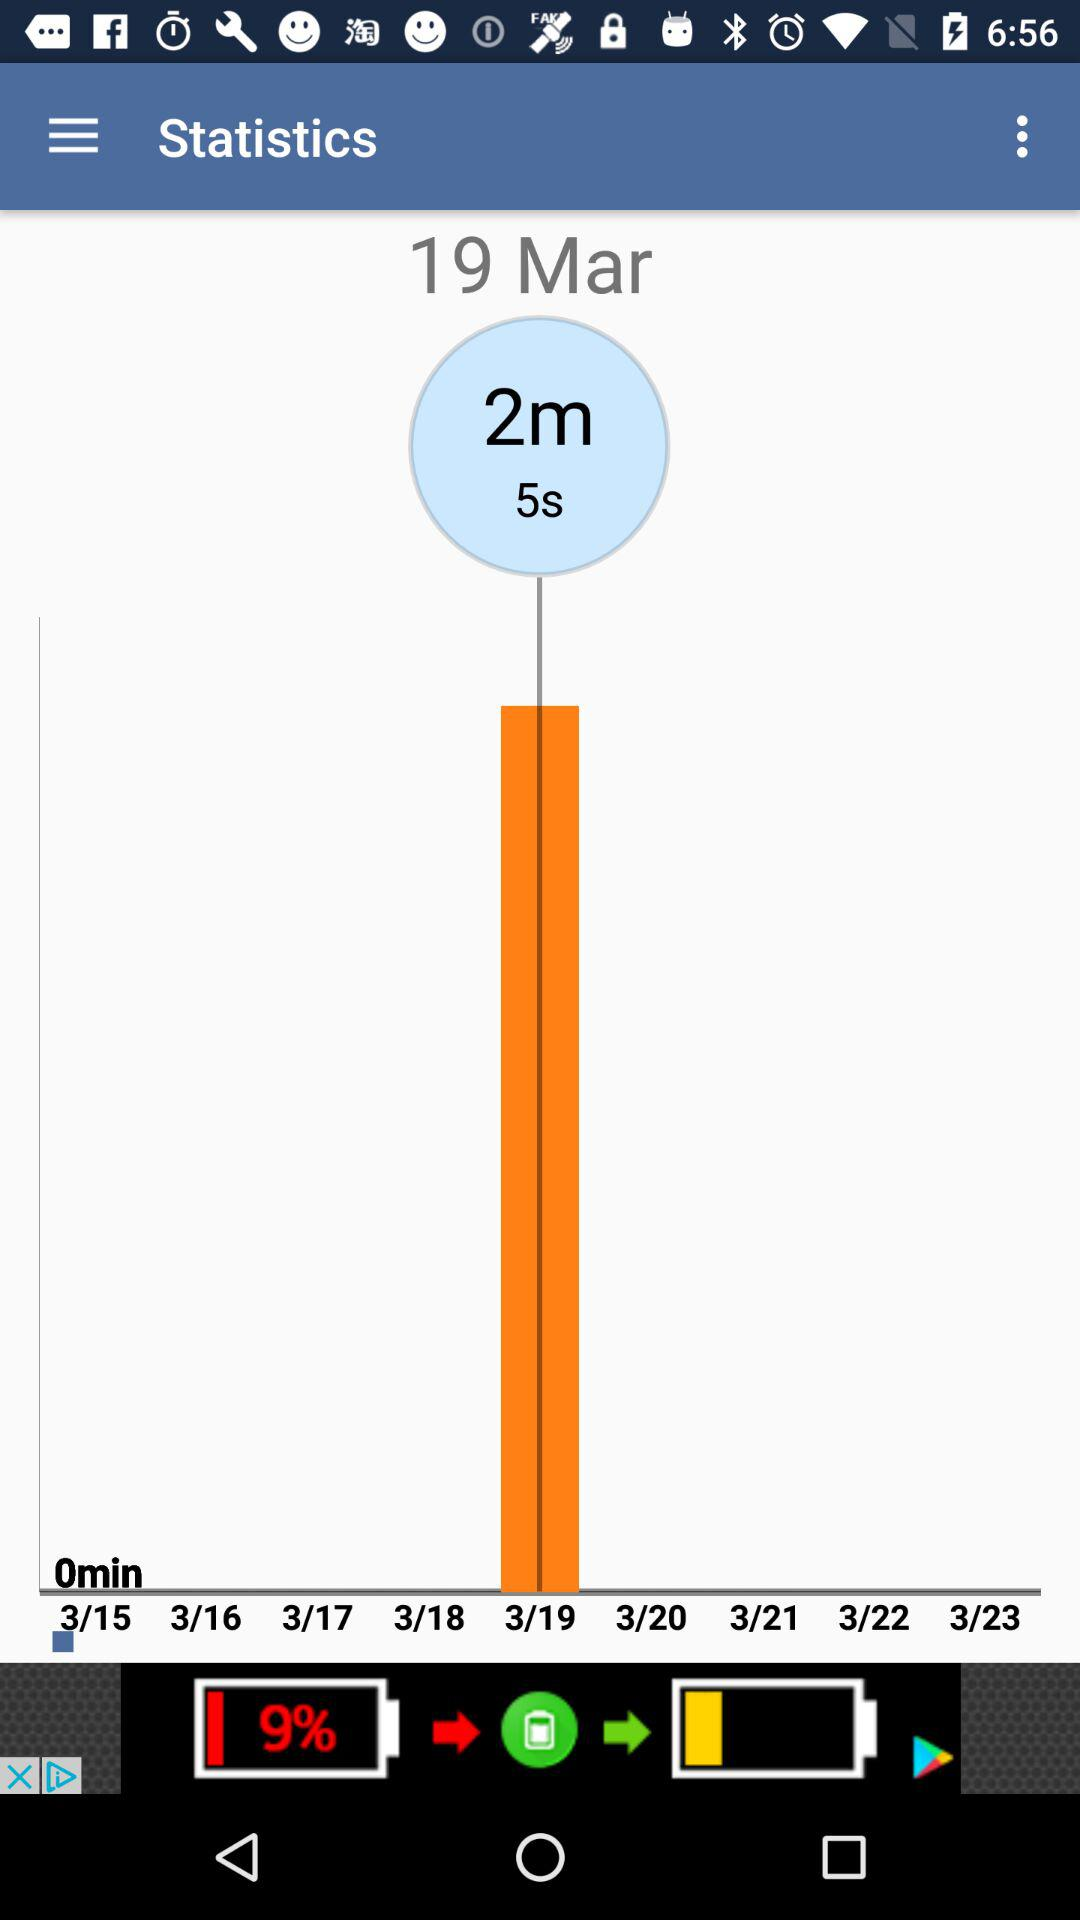How many days are there between the first and last dates shown?
Answer the question using a single word or phrase. 8 